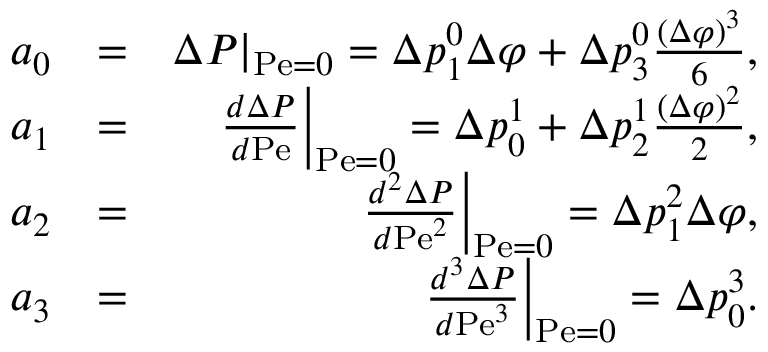<formula> <loc_0><loc_0><loc_500><loc_500>\begin{array} { r l r } { a _ { 0 } } & { = } & { \Delta P | _ { P e = 0 } = \Delta p _ { 1 } ^ { 0 } \Delta \varphi + \Delta p _ { 3 } ^ { 0 } \frac { ( \Delta \varphi ) ^ { 3 } } { 6 } , } \\ { a _ { 1 } } & { = } & { \frac { d \Delta P } { d P e } \right | _ { P e = 0 } = \Delta p _ { 0 } ^ { 1 } + \Delta p _ { 2 } ^ { 1 } \frac { ( \Delta \varphi ) ^ { 2 } } { 2 } , } \\ { a _ { 2 } } & { = } & { \frac { d ^ { 2 } \Delta P } { d P e ^ { 2 } } \right | _ { P e = 0 } = \Delta p _ { 1 } ^ { 2 } \Delta \varphi , } \\ { a _ { 3 } } & { = } & { \frac { d ^ { 3 } \Delta P } { d P e ^ { 3 } } \right | _ { P e = 0 } = \Delta p _ { 0 } ^ { 3 } . } \end{array}</formula> 